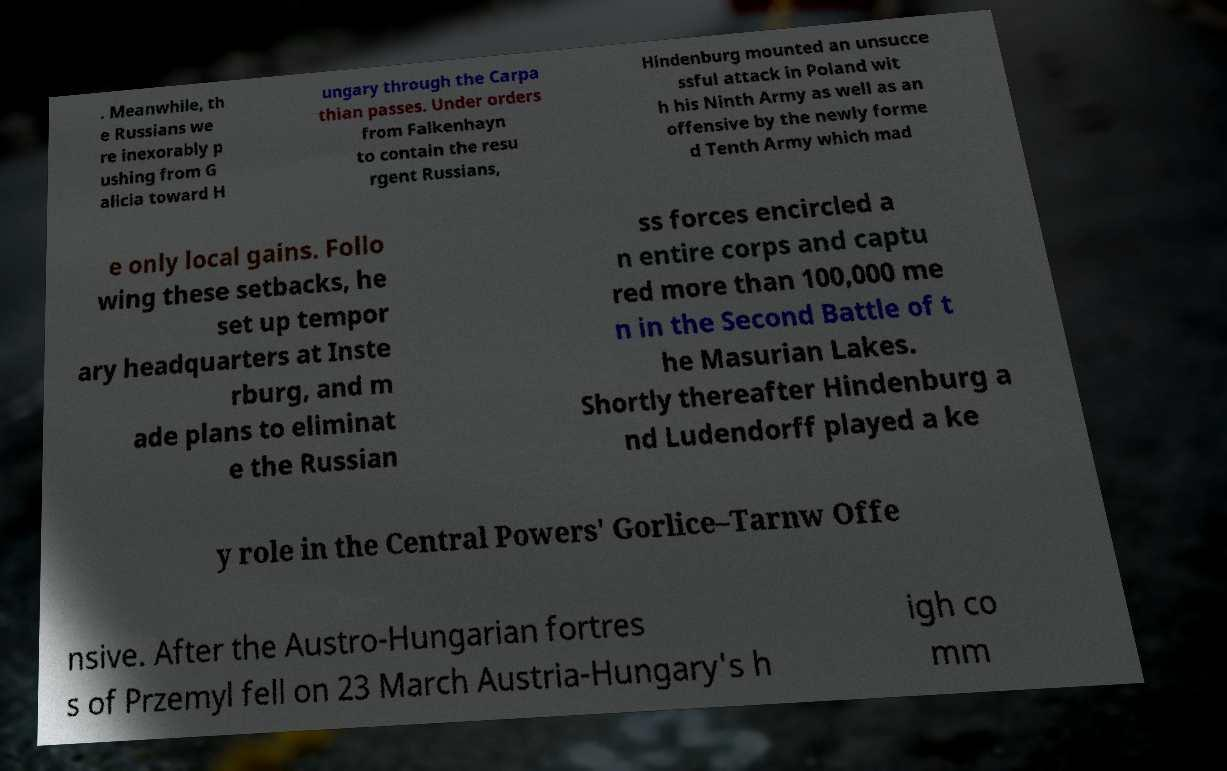There's text embedded in this image that I need extracted. Can you transcribe it verbatim? . Meanwhile, th e Russians we re inexorably p ushing from G alicia toward H ungary through the Carpa thian passes. Under orders from Falkenhayn to contain the resu rgent Russians, Hindenburg mounted an unsucce ssful attack in Poland wit h his Ninth Army as well as an offensive by the newly forme d Tenth Army which mad e only local gains. Follo wing these setbacks, he set up tempor ary headquarters at Inste rburg, and m ade plans to eliminat e the Russian ss forces encircled a n entire corps and captu red more than 100,000 me n in the Second Battle of t he Masurian Lakes. Shortly thereafter Hindenburg a nd Ludendorff played a ke y role in the Central Powers' Gorlice–Tarnw Offe nsive. After the Austro-Hungarian fortres s of Przemyl fell on 23 March Austria-Hungary's h igh co mm 